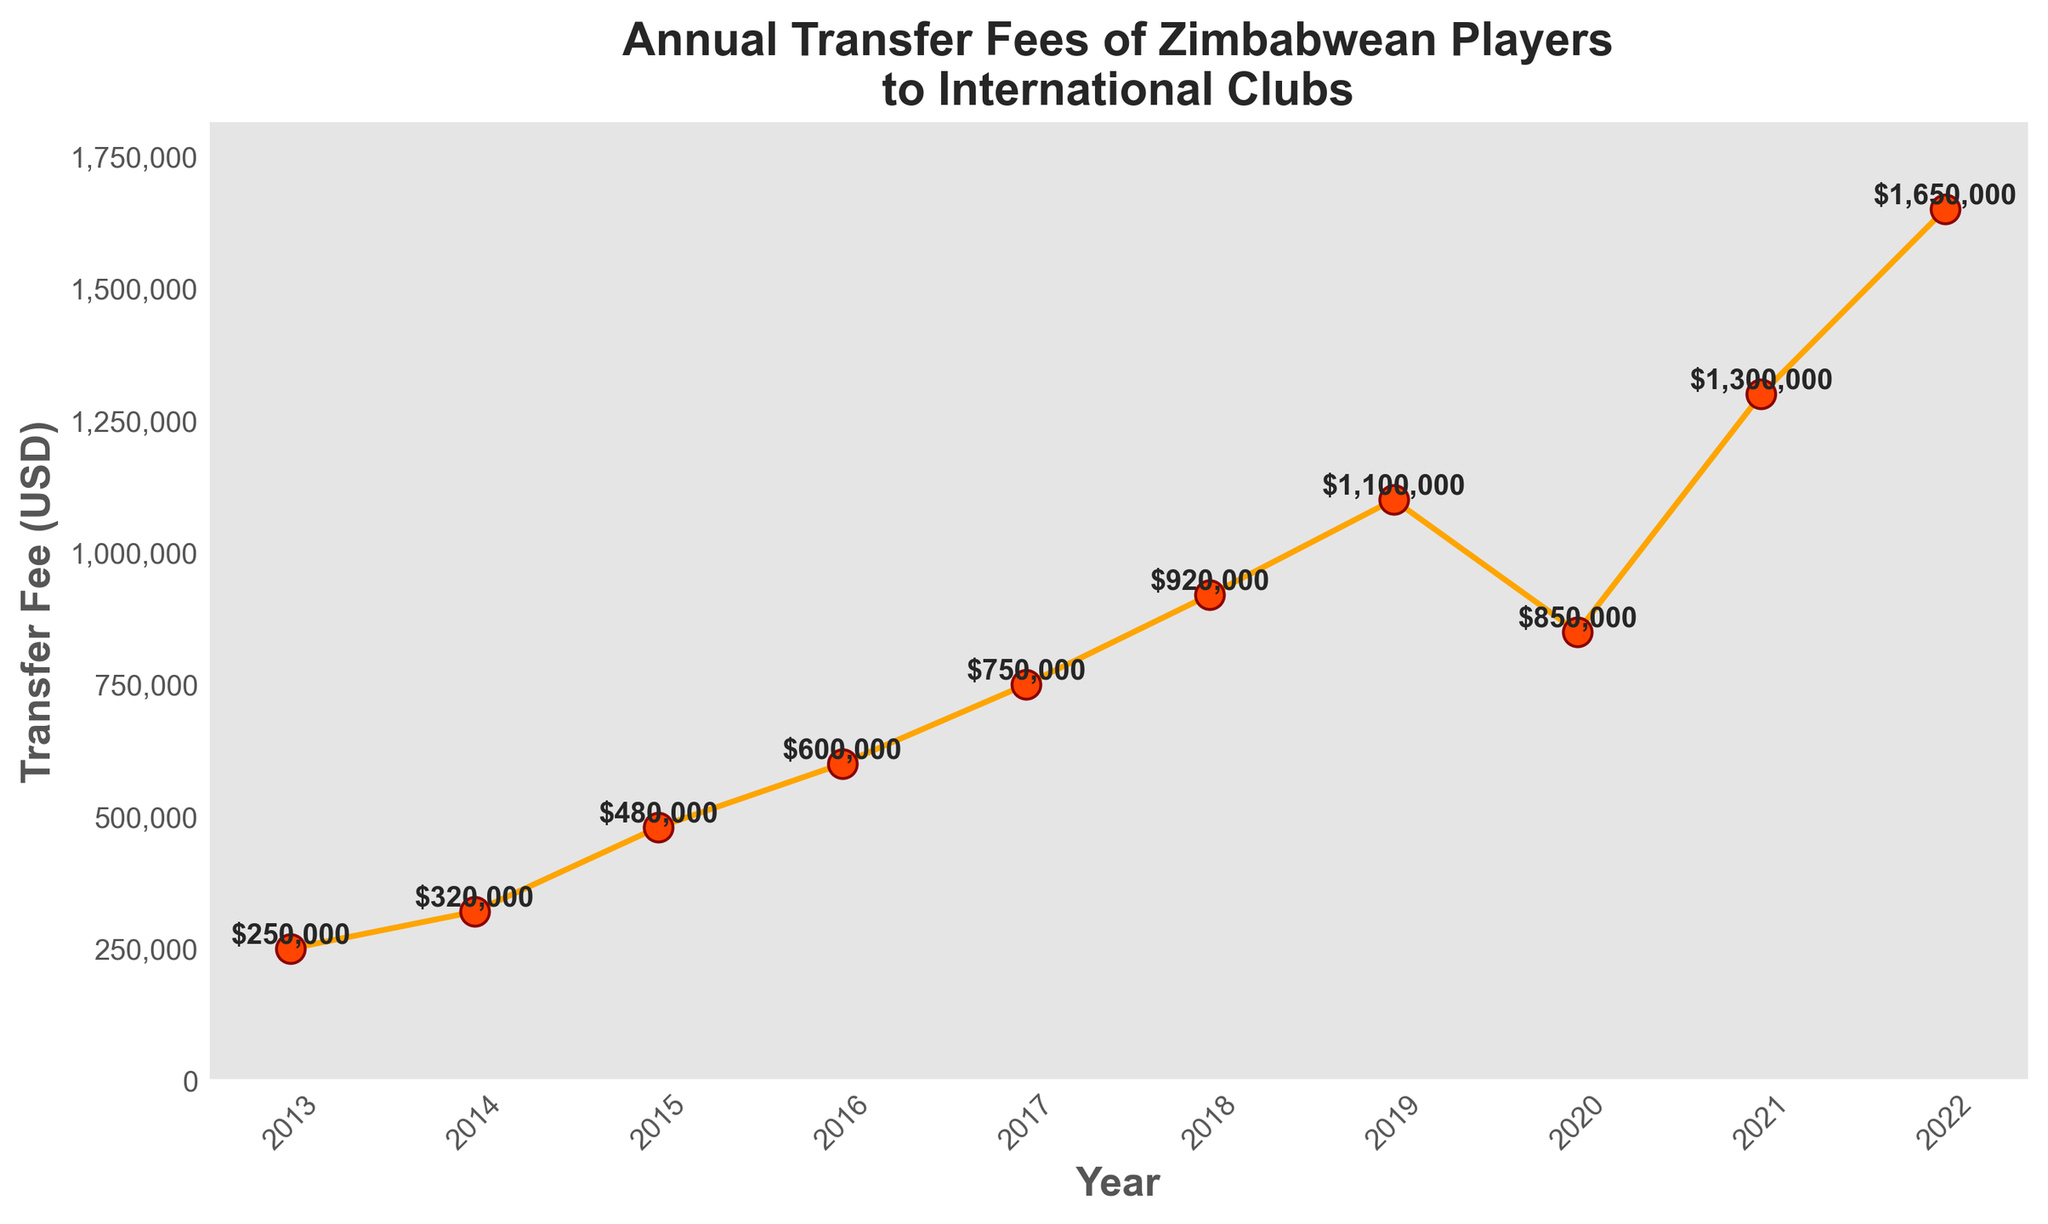What was the transfer fee in 2022? Look at the data point for the year 2022, the marker at that point shows the transfer fee
Answer: 1,650,000 In which year did the transfer fee first exceed 1 million USD? Scan the x-axis from left to right and find the first year where the transfer fee value on the y-axis is above 1 million USD
Answer: 2019 Between which consecutive years did the transfer fee increase the most? Calculate the difference in transfer fees between each pair of consecutive years, the pair with the biggest difference is the answer. For instance, between 2014 to 2015 is 480,000 - 320,000 = 160,000, and so on
Answer: 2019 to 2020 How many years had transfer fees below 500,000 USD? Identify the years where the transfer fee value on the y-axis is below 500,000 USD and count them
Answer: 3 What is the average transfer fee for the years between 2017 and 2020 inclusive? Sum the transfer fees for the years 2017 to 2020: 750,000 + 920,000 + 1,100,000 + 850,000, and divide by the number of years (4)
Answer: $905,000 During what range of years did the transfer fee show a consistent increase? Look for a period where each year’s transfer fee is higher than the previous year; visually scan for an increasing slope without decreases
Answer: 2013 to 2019 What was the visual marker face color used in the plot? Observe the visual attribute concerning the marker face color used for the dots representing transfer fees
Answer: Orange Red Which year had the biggest single-year drop in transfer fees? Identify the year where the difference between transfer fees of that year and the previous year is the largest negative number
Answer: 2020 What is the total sum of transfer fees from 2013 to 2015? Add the transfer fees for the years 2013, 2014, and 2015: 250,000 + 320,000 + 480,000
Answer: 1,050,000 Was the transfer fee higher in 2020 or 2021? Compare the transfer fees of 2020 and 2021 visually; identify which marker is higher on the y-axis
Answer: 2021 